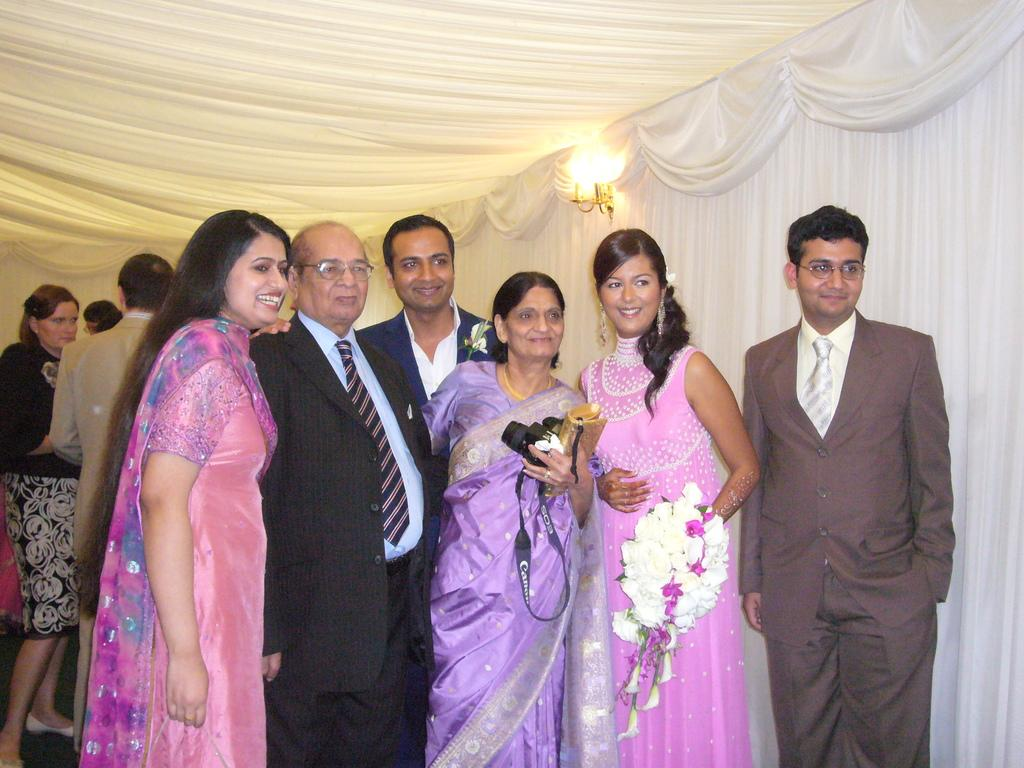What are the two people holding in their hands? There are two people holding objects in their hands, but the specific objects are not mentioned in the facts. How many people are standing in the image? There are a few people standing in the image. What can be observed about the lighting in the image? There is light in the image. What type of window treatment is present in the image? There are curtains in the image. How does the beggar in the image request for sugar? There is no beggar present in the image, and therefore no such interaction can be observed. 